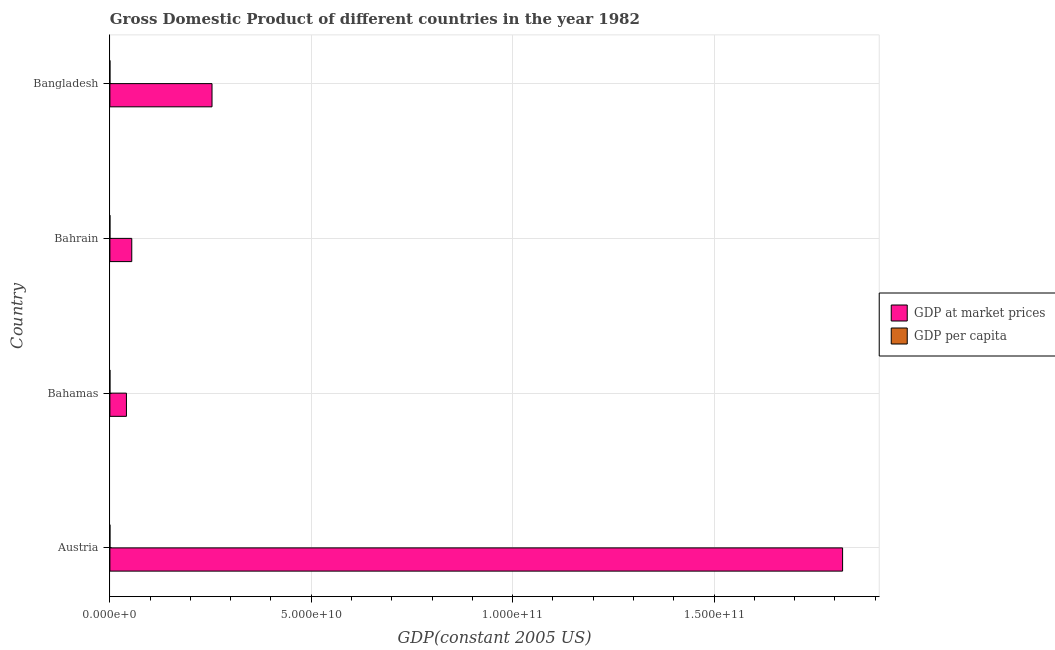Are the number of bars on each tick of the Y-axis equal?
Your answer should be very brief. Yes. How many bars are there on the 1st tick from the top?
Keep it short and to the point. 2. What is the gdp at market prices in Austria?
Ensure brevity in your answer.  1.82e+11. Across all countries, what is the maximum gdp per capita?
Offer a very short reply. 2.40e+04. Across all countries, what is the minimum gdp per capita?
Keep it short and to the point. 295.31. In which country was the gdp at market prices minimum?
Provide a short and direct response. Bahamas. What is the total gdp at market prices in the graph?
Keep it short and to the point. 2.17e+11. What is the difference between the gdp at market prices in Austria and that in Bahrain?
Offer a very short reply. 1.76e+11. What is the difference between the gdp per capita in Austria and the gdp at market prices in Bahamas?
Provide a succinct answer. -4.11e+09. What is the average gdp per capita per country?
Ensure brevity in your answer.  1.43e+04. What is the difference between the gdp at market prices and gdp per capita in Bahamas?
Your response must be concise. 4.11e+09. In how many countries, is the gdp at market prices greater than 20000000000 US$?
Give a very brief answer. 2. What is the ratio of the gdp per capita in Bahamas to that in Bahrain?
Provide a short and direct response. 1.32. Is the gdp at market prices in Austria less than that in Bahamas?
Provide a short and direct response. No. What is the difference between the highest and the second highest gdp per capita?
Give a very brief answer. 5366.53. What is the difference between the highest and the lowest gdp per capita?
Your answer should be compact. 2.37e+04. In how many countries, is the gdp per capita greater than the average gdp per capita taken over all countries?
Your answer should be compact. 2. Is the sum of the gdp per capita in Bahrain and Bangladesh greater than the maximum gdp at market prices across all countries?
Keep it short and to the point. No. What does the 2nd bar from the top in Bahamas represents?
Offer a terse response. GDP at market prices. What does the 2nd bar from the bottom in Bahamas represents?
Give a very brief answer. GDP per capita. How many bars are there?
Make the answer very short. 8. Are all the bars in the graph horizontal?
Provide a short and direct response. Yes. What is the difference between two consecutive major ticks on the X-axis?
Your answer should be compact. 5.00e+1. Does the graph contain any zero values?
Offer a terse response. No. Does the graph contain grids?
Your answer should be compact. Yes. How many legend labels are there?
Ensure brevity in your answer.  2. How are the legend labels stacked?
Provide a short and direct response. Vertical. What is the title of the graph?
Offer a terse response. Gross Domestic Product of different countries in the year 1982. What is the label or title of the X-axis?
Provide a short and direct response. GDP(constant 2005 US). What is the label or title of the Y-axis?
Keep it short and to the point. Country. What is the GDP(constant 2005 US) of GDP at market prices in Austria?
Ensure brevity in your answer.  1.82e+11. What is the GDP(constant 2005 US) of GDP per capita in Austria?
Offer a terse response. 2.40e+04. What is the GDP(constant 2005 US) in GDP at market prices in Bahamas?
Your response must be concise. 4.11e+09. What is the GDP(constant 2005 US) in GDP per capita in Bahamas?
Give a very brief answer. 1.87e+04. What is the GDP(constant 2005 US) of GDP at market prices in Bahrain?
Make the answer very short. 5.43e+09. What is the GDP(constant 2005 US) of GDP per capita in Bahrain?
Ensure brevity in your answer.  1.41e+04. What is the GDP(constant 2005 US) in GDP at market prices in Bangladesh?
Offer a very short reply. 2.54e+1. What is the GDP(constant 2005 US) in GDP per capita in Bangladesh?
Offer a very short reply. 295.31. Across all countries, what is the maximum GDP(constant 2005 US) in GDP at market prices?
Keep it short and to the point. 1.82e+11. Across all countries, what is the maximum GDP(constant 2005 US) of GDP per capita?
Give a very brief answer. 2.40e+04. Across all countries, what is the minimum GDP(constant 2005 US) of GDP at market prices?
Offer a terse response. 4.11e+09. Across all countries, what is the minimum GDP(constant 2005 US) in GDP per capita?
Make the answer very short. 295.31. What is the total GDP(constant 2005 US) of GDP at market prices in the graph?
Keep it short and to the point. 2.17e+11. What is the total GDP(constant 2005 US) in GDP per capita in the graph?
Provide a short and direct response. 5.70e+04. What is the difference between the GDP(constant 2005 US) of GDP at market prices in Austria and that in Bahamas?
Ensure brevity in your answer.  1.78e+11. What is the difference between the GDP(constant 2005 US) in GDP per capita in Austria and that in Bahamas?
Your answer should be compact. 5366.53. What is the difference between the GDP(constant 2005 US) of GDP at market prices in Austria and that in Bahrain?
Ensure brevity in your answer.  1.76e+11. What is the difference between the GDP(constant 2005 US) of GDP per capita in Austria and that in Bahrain?
Provide a short and direct response. 9947.04. What is the difference between the GDP(constant 2005 US) in GDP at market prices in Austria and that in Bangladesh?
Ensure brevity in your answer.  1.57e+11. What is the difference between the GDP(constant 2005 US) of GDP per capita in Austria and that in Bangladesh?
Your answer should be very brief. 2.37e+04. What is the difference between the GDP(constant 2005 US) in GDP at market prices in Bahamas and that in Bahrain?
Make the answer very short. -1.32e+09. What is the difference between the GDP(constant 2005 US) in GDP per capita in Bahamas and that in Bahrain?
Give a very brief answer. 4580.52. What is the difference between the GDP(constant 2005 US) of GDP at market prices in Bahamas and that in Bangladesh?
Provide a succinct answer. -2.12e+1. What is the difference between the GDP(constant 2005 US) of GDP per capita in Bahamas and that in Bangladesh?
Your response must be concise. 1.84e+04. What is the difference between the GDP(constant 2005 US) of GDP at market prices in Bahrain and that in Bangladesh?
Make the answer very short. -1.99e+1. What is the difference between the GDP(constant 2005 US) of GDP per capita in Bahrain and that in Bangladesh?
Your answer should be compact. 1.38e+04. What is the difference between the GDP(constant 2005 US) of GDP at market prices in Austria and the GDP(constant 2005 US) of GDP per capita in Bahamas?
Your answer should be compact. 1.82e+11. What is the difference between the GDP(constant 2005 US) of GDP at market prices in Austria and the GDP(constant 2005 US) of GDP per capita in Bahrain?
Provide a succinct answer. 1.82e+11. What is the difference between the GDP(constant 2005 US) in GDP at market prices in Austria and the GDP(constant 2005 US) in GDP per capita in Bangladesh?
Provide a short and direct response. 1.82e+11. What is the difference between the GDP(constant 2005 US) of GDP at market prices in Bahamas and the GDP(constant 2005 US) of GDP per capita in Bahrain?
Keep it short and to the point. 4.11e+09. What is the difference between the GDP(constant 2005 US) of GDP at market prices in Bahamas and the GDP(constant 2005 US) of GDP per capita in Bangladesh?
Offer a very short reply. 4.11e+09. What is the difference between the GDP(constant 2005 US) in GDP at market prices in Bahrain and the GDP(constant 2005 US) in GDP per capita in Bangladesh?
Your answer should be very brief. 5.43e+09. What is the average GDP(constant 2005 US) in GDP at market prices per country?
Keep it short and to the point. 5.42e+1. What is the average GDP(constant 2005 US) in GDP per capita per country?
Your response must be concise. 1.43e+04. What is the difference between the GDP(constant 2005 US) in GDP at market prices and GDP(constant 2005 US) in GDP per capita in Austria?
Offer a terse response. 1.82e+11. What is the difference between the GDP(constant 2005 US) in GDP at market prices and GDP(constant 2005 US) in GDP per capita in Bahamas?
Your response must be concise. 4.11e+09. What is the difference between the GDP(constant 2005 US) of GDP at market prices and GDP(constant 2005 US) of GDP per capita in Bahrain?
Ensure brevity in your answer.  5.43e+09. What is the difference between the GDP(constant 2005 US) of GDP at market prices and GDP(constant 2005 US) of GDP per capita in Bangladesh?
Offer a terse response. 2.54e+1. What is the ratio of the GDP(constant 2005 US) of GDP at market prices in Austria to that in Bahamas?
Keep it short and to the point. 44.28. What is the ratio of the GDP(constant 2005 US) of GDP per capita in Austria to that in Bahamas?
Offer a very short reply. 1.29. What is the ratio of the GDP(constant 2005 US) of GDP at market prices in Austria to that in Bahrain?
Keep it short and to the point. 33.5. What is the ratio of the GDP(constant 2005 US) in GDP per capita in Austria to that in Bahrain?
Give a very brief answer. 1.71. What is the ratio of the GDP(constant 2005 US) of GDP at market prices in Austria to that in Bangladesh?
Keep it short and to the point. 7.17. What is the ratio of the GDP(constant 2005 US) of GDP per capita in Austria to that in Bangladesh?
Make the answer very short. 81.34. What is the ratio of the GDP(constant 2005 US) of GDP at market prices in Bahamas to that in Bahrain?
Your answer should be compact. 0.76. What is the ratio of the GDP(constant 2005 US) in GDP per capita in Bahamas to that in Bahrain?
Your answer should be very brief. 1.33. What is the ratio of the GDP(constant 2005 US) in GDP at market prices in Bahamas to that in Bangladesh?
Provide a succinct answer. 0.16. What is the ratio of the GDP(constant 2005 US) of GDP per capita in Bahamas to that in Bangladesh?
Keep it short and to the point. 63.16. What is the ratio of the GDP(constant 2005 US) of GDP at market prices in Bahrain to that in Bangladesh?
Offer a very short reply. 0.21. What is the ratio of the GDP(constant 2005 US) of GDP per capita in Bahrain to that in Bangladesh?
Offer a very short reply. 47.65. What is the difference between the highest and the second highest GDP(constant 2005 US) of GDP at market prices?
Your answer should be very brief. 1.57e+11. What is the difference between the highest and the second highest GDP(constant 2005 US) of GDP per capita?
Provide a succinct answer. 5366.53. What is the difference between the highest and the lowest GDP(constant 2005 US) in GDP at market prices?
Provide a short and direct response. 1.78e+11. What is the difference between the highest and the lowest GDP(constant 2005 US) in GDP per capita?
Provide a succinct answer. 2.37e+04. 